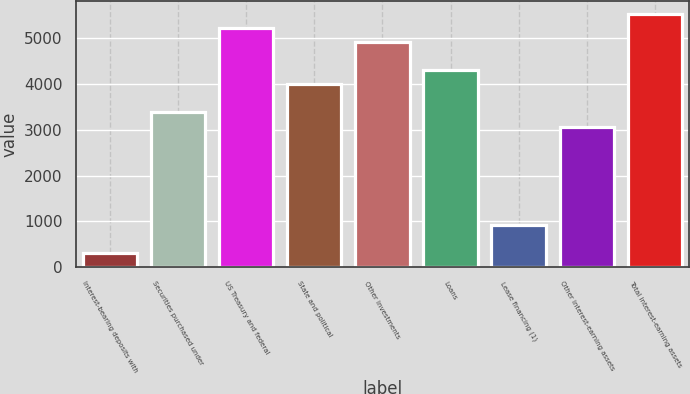Convert chart to OTSL. <chart><loc_0><loc_0><loc_500><loc_500><bar_chart><fcel>Interest-bearing deposits with<fcel>Securities purchased under<fcel>US Treasury and federal<fcel>State and political<fcel>Other investments<fcel>Loans<fcel>Lease financing (1)<fcel>Other interest-earning assets<fcel>Total interest-earning assets<nl><fcel>309.3<fcel>3382.3<fcel>5226.1<fcel>3996.9<fcel>4918.8<fcel>4304.2<fcel>923.9<fcel>3075<fcel>5533.4<nl></chart> 